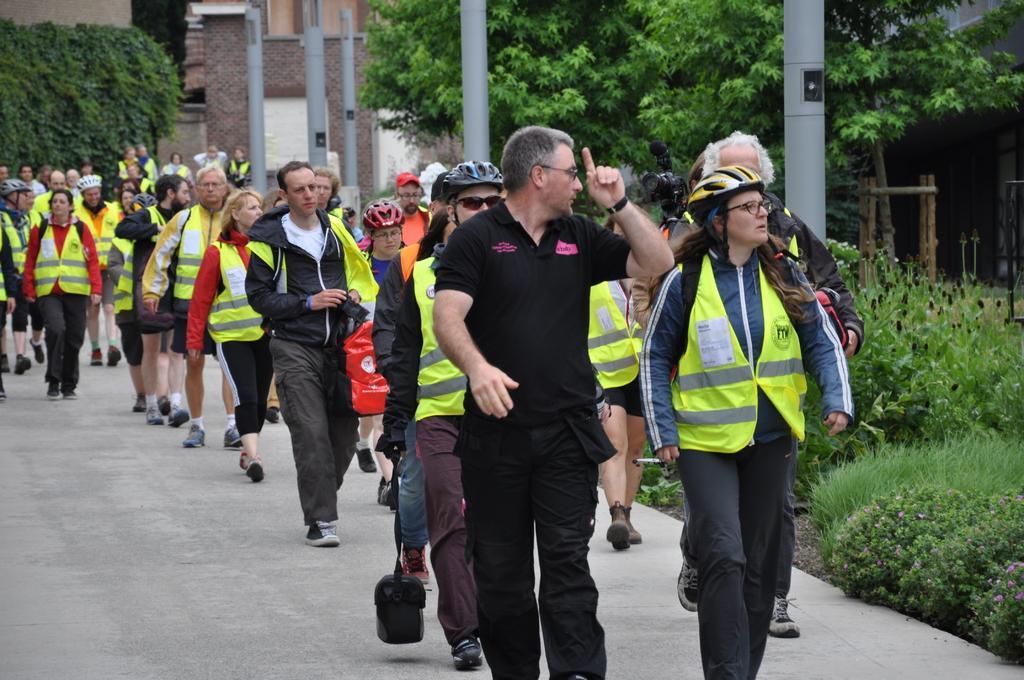Could you give a brief overview of what you see in this image? In this image people are walking on a path, on the right side there plants, trees, poles, in the background there is a building and a plant. 